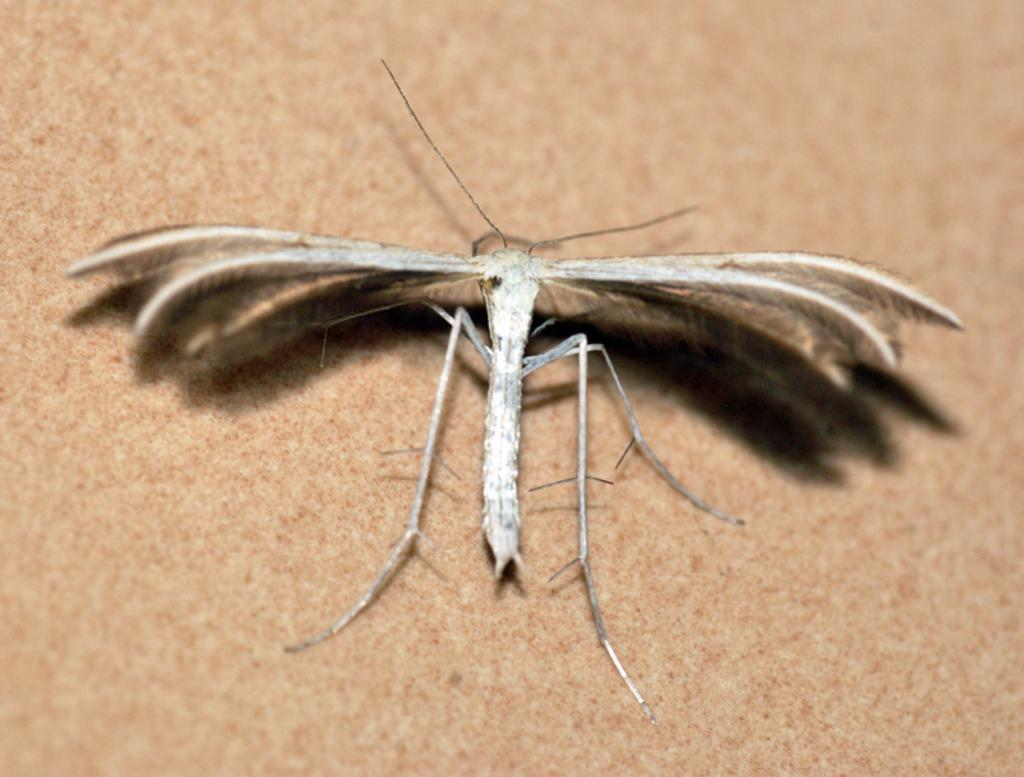What type of creature is in the image? There is an insect in the image. Where is the insect located in the image? The insect is in the front of the image. What is at the bottom of the image? There is a mat at the bottom of the image. Can you tell me how the insect is helping to make the soup in the image? There is no soup present in the image, and the insect is not performing any actions related to cooking or food preparation. 